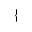Convert formula to latex. <formula><loc_0><loc_0><loc_500><loc_500>\{</formula> 